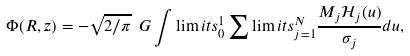<formula> <loc_0><loc_0><loc_500><loc_500>\Phi ( R , z ) = - \sqrt { 2 / \pi } \ G \int \lim i t s _ { 0 } ^ { 1 } \sum \lim i t s _ { j = 1 } ^ { N } \frac { M _ { j } \mathcal { H } _ { j } ( u ) } { \sigma _ { j } } d u ,</formula> 